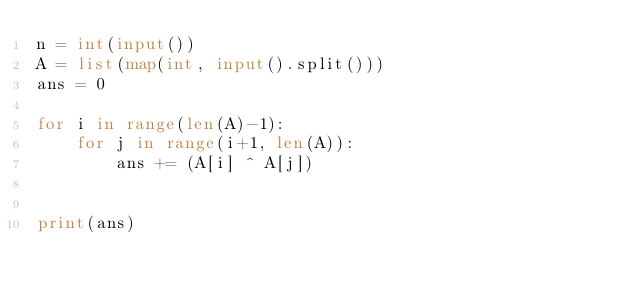<code> <loc_0><loc_0><loc_500><loc_500><_Python_>n = int(input())
A = list(map(int, input().split()))
ans = 0

for i in range(len(A)-1):
    for j in range(i+1, len(A)):
        ans += (A[i] ^ A[j])


print(ans)
</code> 